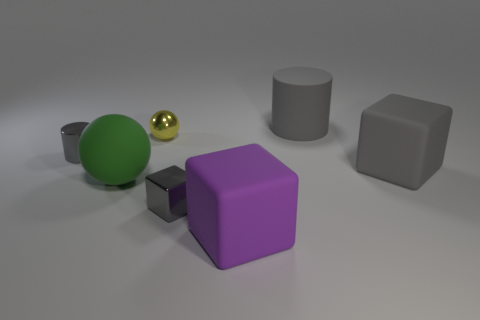How big is the gray thing that is to the right of the big ball and to the left of the big gray matte cylinder?
Ensure brevity in your answer.  Small. Is the color of the ball in front of the tiny cylinder the same as the large cube that is right of the large gray rubber cylinder?
Your answer should be very brief. No. How many big balls are to the right of the gray rubber cylinder?
Ensure brevity in your answer.  0. There is a object that is right of the big object that is behind the shiny ball; are there any small objects behind it?
Ensure brevity in your answer.  Yes. How many blocks are the same size as the yellow object?
Offer a terse response. 1. What material is the gray cube right of the large matte thing that is in front of the green matte sphere?
Offer a terse response. Rubber. There is a small gray object right of the big ball that is on the left side of the small metal thing that is behind the small cylinder; what shape is it?
Offer a terse response. Cube. Do the small shiny thing that is behind the small gray cylinder and the tiny gray thing right of the tiny shiny cylinder have the same shape?
Your answer should be compact. No. What number of other things are there of the same material as the tiny ball
Make the answer very short. 2. There is a tiny yellow object that is made of the same material as the tiny gray cylinder; what is its shape?
Provide a short and direct response. Sphere. 